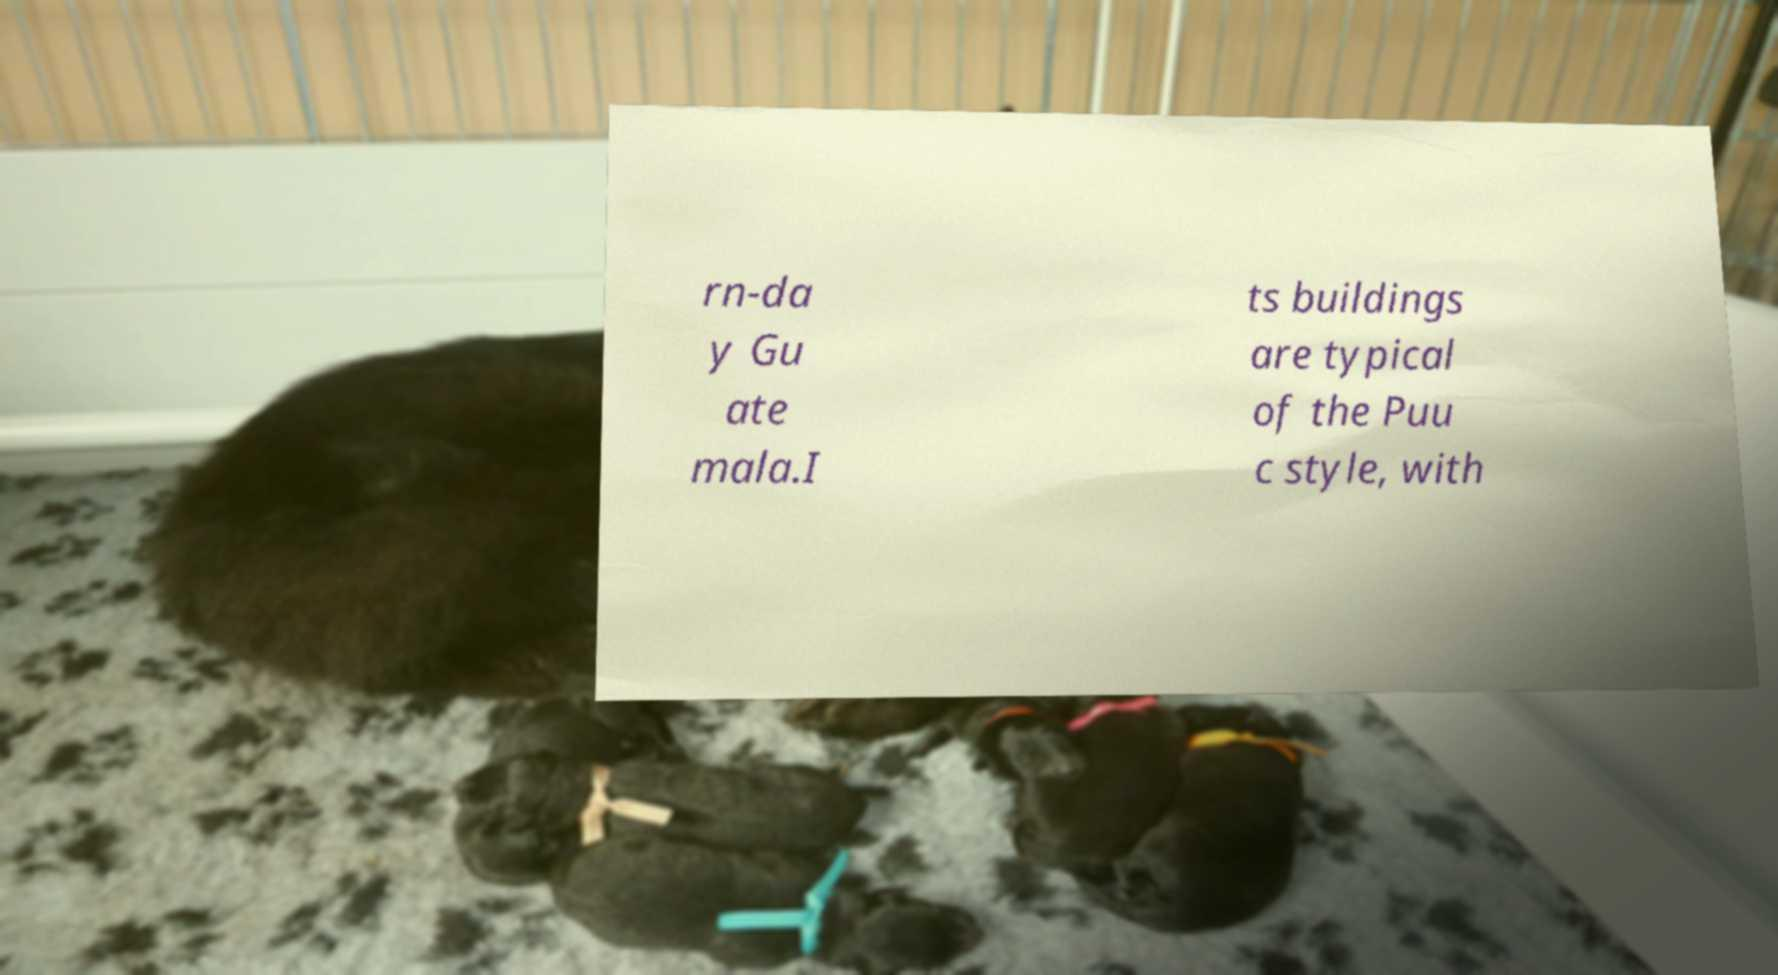Can you accurately transcribe the text from the provided image for me? rn-da y Gu ate mala.I ts buildings are typical of the Puu c style, with 